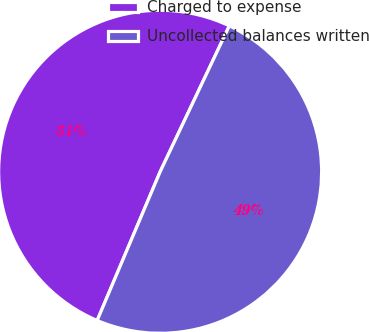Convert chart. <chart><loc_0><loc_0><loc_500><loc_500><pie_chart><fcel>Charged to expense<fcel>Uncollected balances written<nl><fcel>50.67%<fcel>49.33%<nl></chart> 